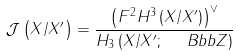Convert formula to latex. <formula><loc_0><loc_0><loc_500><loc_500>\mathcal { J } \left ( X / X ^ { \prime } \right ) = \frac { \left ( F ^ { 2 } H ^ { 3 } \left ( X / X ^ { \prime } \right ) \right ) ^ { \vee } } { H _ { 3 } \left ( X / X ^ { \prime } ; \ \ B b b { Z } \right ) }</formula> 